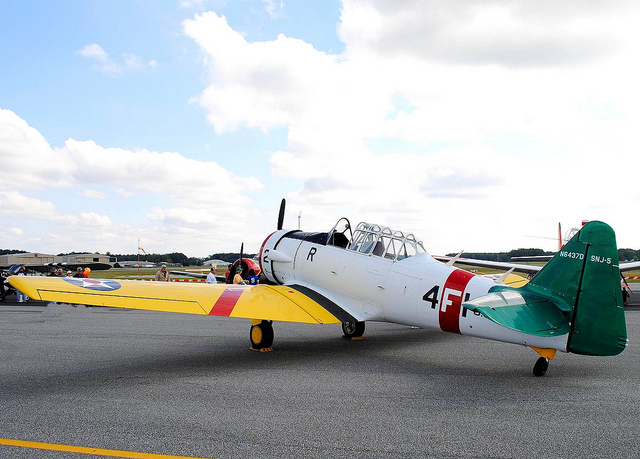Please extract the text content from this image. 2 R 4FI SNJ 